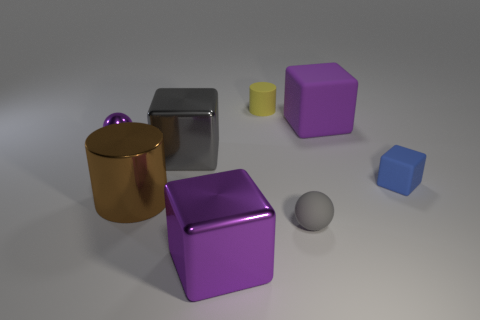Add 1 yellow rubber things. How many objects exist? 9 Add 6 small purple cylinders. How many small purple cylinders exist? 6 Subtract 0 cyan blocks. How many objects are left? 8 Subtract all small brown shiny blocks. Subtract all tiny rubber balls. How many objects are left? 7 Add 2 yellow things. How many yellow things are left? 3 